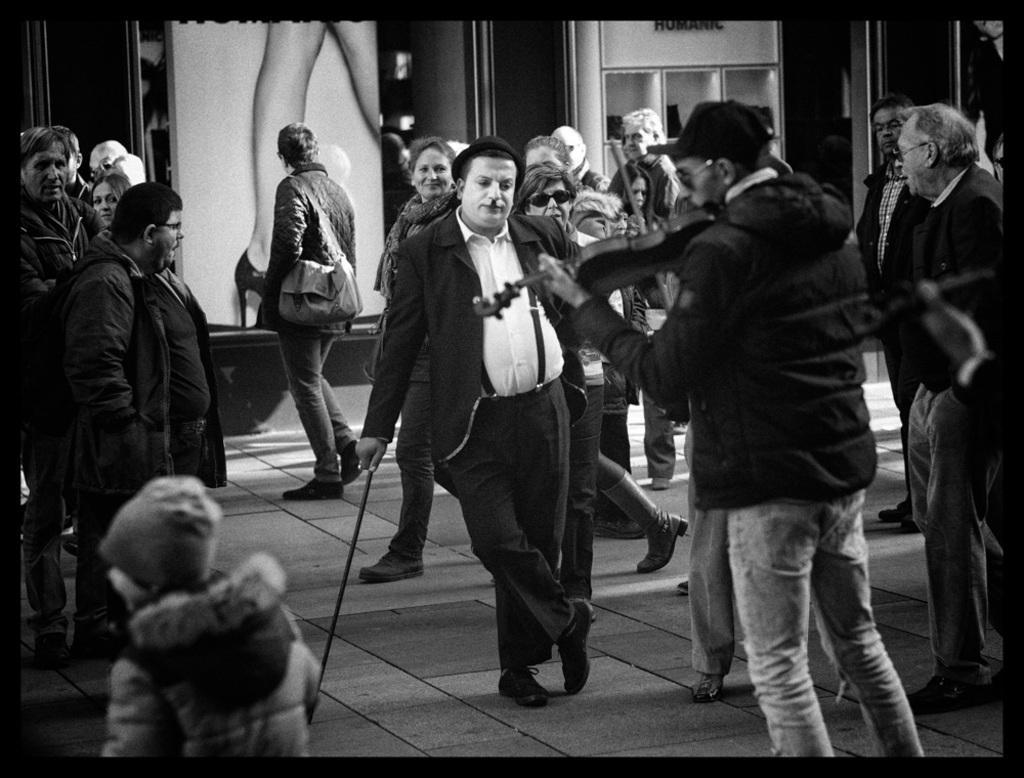Please provide a concise description of this image. It is a black and white image. In this image we can see people. We can see a man wearing the face painting and holding the stick and standing on the path. We can also see another man playing the guitar. In the background we can see the hoarding with woman legs and also the heel. We can also see the rack and the image has borders. 